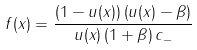<formula> <loc_0><loc_0><loc_500><loc_500>f ( x ) = \frac { \left ( 1 - u ( x ) \right ) \left ( u ( x ) - \beta \right ) } { u ( x ) \left ( 1 + \beta \right ) c _ { - } }</formula> 